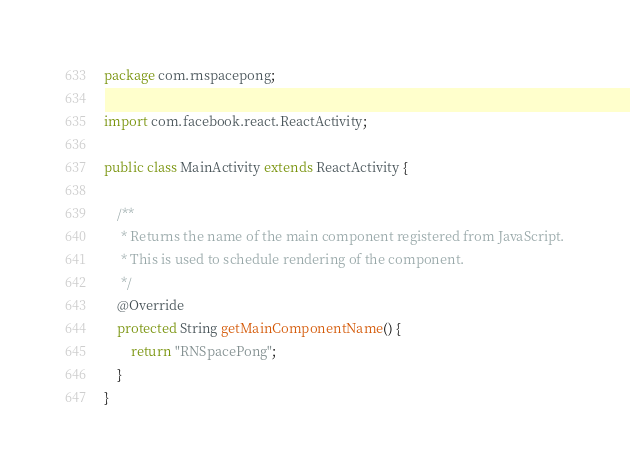Convert code to text. <code><loc_0><loc_0><loc_500><loc_500><_Java_>package com.rnspacepong;

import com.facebook.react.ReactActivity;

public class MainActivity extends ReactActivity {

    /**
     * Returns the name of the main component registered from JavaScript.
     * This is used to schedule rendering of the component.
     */
    @Override
    protected String getMainComponentName() {
        return "RNSpacePong";
    }
}
</code> 